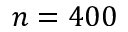<formula> <loc_0><loc_0><loc_500><loc_500>n = 4 0 0</formula> 